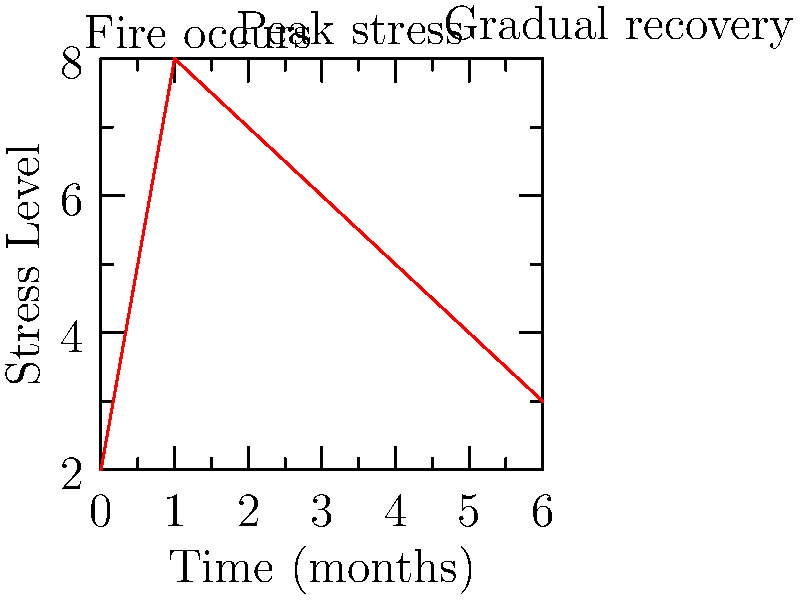Analyze the graph depicting stress levels in families affected by house fires over time. What psychological phenomenon does the curve's shape suggest, and how might this inform support strategies for firefighters assisting victims? 1. Initial state (Time = 0): The graph starts at a relatively low stress level, representing the family's state before the fire.

2. Immediate spike (Time = 1): There's a sharp increase in stress levels, reaching the peak. This represents the immediate aftermath of the fire, where families experience acute stress and trauma.

3. Gradual decline (Time = 2 to 6): The stress levels show a gradual decrease over time, suggesting a recovery process.

4. Curve shape analysis: The overall shape resembles an acute stress response curve, also known as the General Adaptation Syndrome (GAS) model proposed by Hans Selye.

5. Psychological phenomenon: This curve suggests resilience - the ability to recover from adversity over time. However, the stress levels don't return to the initial baseline, indicating lasting effects.

6. Implications for support strategies:
   a) Immediate intervention: The sharp spike suggests a need for immediate crisis intervention and support.
   b) Long-term support: The gradual decline indicates a need for ongoing support services.
   c) Monitoring: Regular check-ins may be beneficial as stress levels remain elevated even after several months.
   d) Targeted interventions: Support can be tailored to different stages of recovery based on the curve.

7. Firefighter's role: Understanding this curve can help firefighters provide more empathetic support, recognize the long-term impact of their work, and potentially advocate for comprehensive support services for fire victims.
Answer: Resilience with lasting effects, necessitating immediate and long-term support strategies 